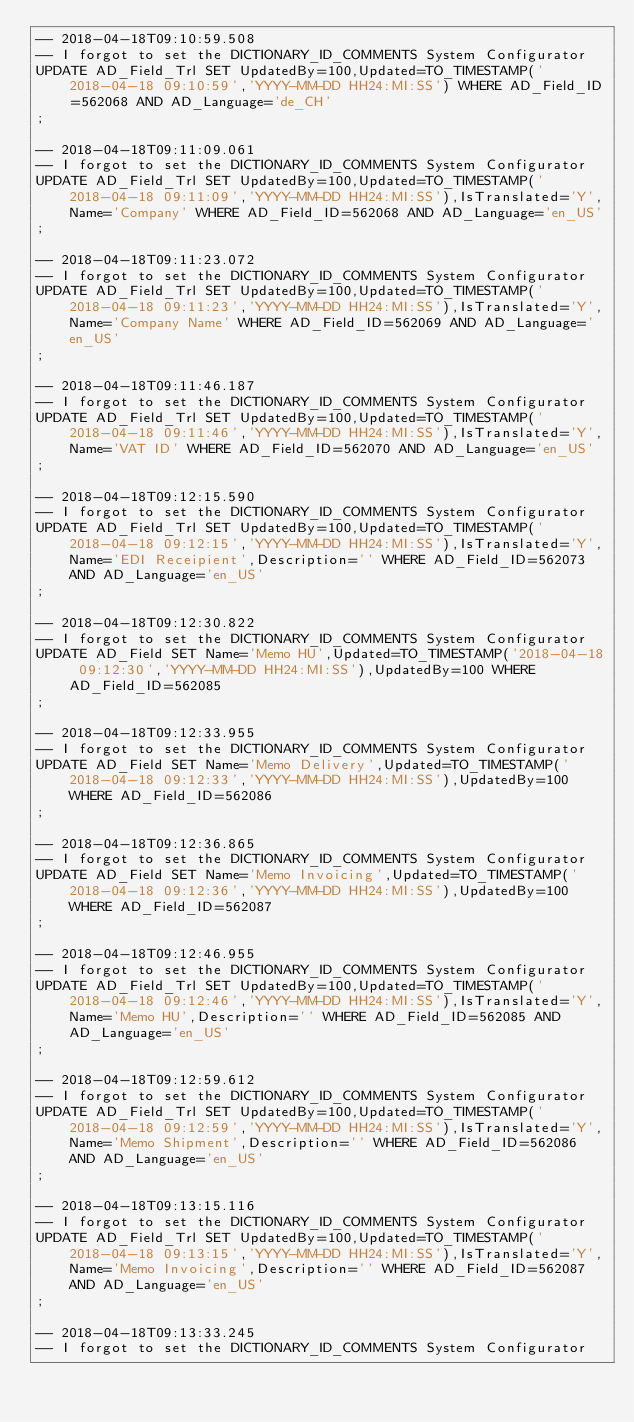Convert code to text. <code><loc_0><loc_0><loc_500><loc_500><_SQL_>-- 2018-04-18T09:10:59.508
-- I forgot to set the DICTIONARY_ID_COMMENTS System Configurator
UPDATE AD_Field_Trl SET UpdatedBy=100,Updated=TO_TIMESTAMP('2018-04-18 09:10:59','YYYY-MM-DD HH24:MI:SS') WHERE AD_Field_ID=562068 AND AD_Language='de_CH'
;

-- 2018-04-18T09:11:09.061
-- I forgot to set the DICTIONARY_ID_COMMENTS System Configurator
UPDATE AD_Field_Trl SET UpdatedBy=100,Updated=TO_TIMESTAMP('2018-04-18 09:11:09','YYYY-MM-DD HH24:MI:SS'),IsTranslated='Y',Name='Company' WHERE AD_Field_ID=562068 AND AD_Language='en_US'
;

-- 2018-04-18T09:11:23.072
-- I forgot to set the DICTIONARY_ID_COMMENTS System Configurator
UPDATE AD_Field_Trl SET UpdatedBy=100,Updated=TO_TIMESTAMP('2018-04-18 09:11:23','YYYY-MM-DD HH24:MI:SS'),IsTranslated='Y',Name='Company Name' WHERE AD_Field_ID=562069 AND AD_Language='en_US'
;

-- 2018-04-18T09:11:46.187
-- I forgot to set the DICTIONARY_ID_COMMENTS System Configurator
UPDATE AD_Field_Trl SET UpdatedBy=100,Updated=TO_TIMESTAMP('2018-04-18 09:11:46','YYYY-MM-DD HH24:MI:SS'),IsTranslated='Y',Name='VAT ID' WHERE AD_Field_ID=562070 AND AD_Language='en_US'
;

-- 2018-04-18T09:12:15.590
-- I forgot to set the DICTIONARY_ID_COMMENTS System Configurator
UPDATE AD_Field_Trl SET UpdatedBy=100,Updated=TO_TIMESTAMP('2018-04-18 09:12:15','YYYY-MM-DD HH24:MI:SS'),IsTranslated='Y',Name='EDI Receipient',Description='' WHERE AD_Field_ID=562073 AND AD_Language='en_US'
;

-- 2018-04-18T09:12:30.822
-- I forgot to set the DICTIONARY_ID_COMMENTS System Configurator
UPDATE AD_Field SET Name='Memo HU',Updated=TO_TIMESTAMP('2018-04-18 09:12:30','YYYY-MM-DD HH24:MI:SS'),UpdatedBy=100 WHERE AD_Field_ID=562085
;

-- 2018-04-18T09:12:33.955
-- I forgot to set the DICTIONARY_ID_COMMENTS System Configurator
UPDATE AD_Field SET Name='Memo Delivery',Updated=TO_TIMESTAMP('2018-04-18 09:12:33','YYYY-MM-DD HH24:MI:SS'),UpdatedBy=100 WHERE AD_Field_ID=562086
;

-- 2018-04-18T09:12:36.865
-- I forgot to set the DICTIONARY_ID_COMMENTS System Configurator
UPDATE AD_Field SET Name='Memo Invoicing',Updated=TO_TIMESTAMP('2018-04-18 09:12:36','YYYY-MM-DD HH24:MI:SS'),UpdatedBy=100 WHERE AD_Field_ID=562087
;

-- 2018-04-18T09:12:46.955
-- I forgot to set the DICTIONARY_ID_COMMENTS System Configurator
UPDATE AD_Field_Trl SET UpdatedBy=100,Updated=TO_TIMESTAMP('2018-04-18 09:12:46','YYYY-MM-DD HH24:MI:SS'),IsTranslated='Y',Name='Memo HU',Description='' WHERE AD_Field_ID=562085 AND AD_Language='en_US'
;

-- 2018-04-18T09:12:59.612
-- I forgot to set the DICTIONARY_ID_COMMENTS System Configurator
UPDATE AD_Field_Trl SET UpdatedBy=100,Updated=TO_TIMESTAMP('2018-04-18 09:12:59','YYYY-MM-DD HH24:MI:SS'),IsTranslated='Y',Name='Memo Shipment',Description='' WHERE AD_Field_ID=562086 AND AD_Language='en_US'
;

-- 2018-04-18T09:13:15.116
-- I forgot to set the DICTIONARY_ID_COMMENTS System Configurator
UPDATE AD_Field_Trl SET UpdatedBy=100,Updated=TO_TIMESTAMP('2018-04-18 09:13:15','YYYY-MM-DD HH24:MI:SS'),IsTranslated='Y',Name='Memo Invoicing',Description='' WHERE AD_Field_ID=562087 AND AD_Language='en_US'
;

-- 2018-04-18T09:13:33.245
-- I forgot to set the DICTIONARY_ID_COMMENTS System Configurator</code> 